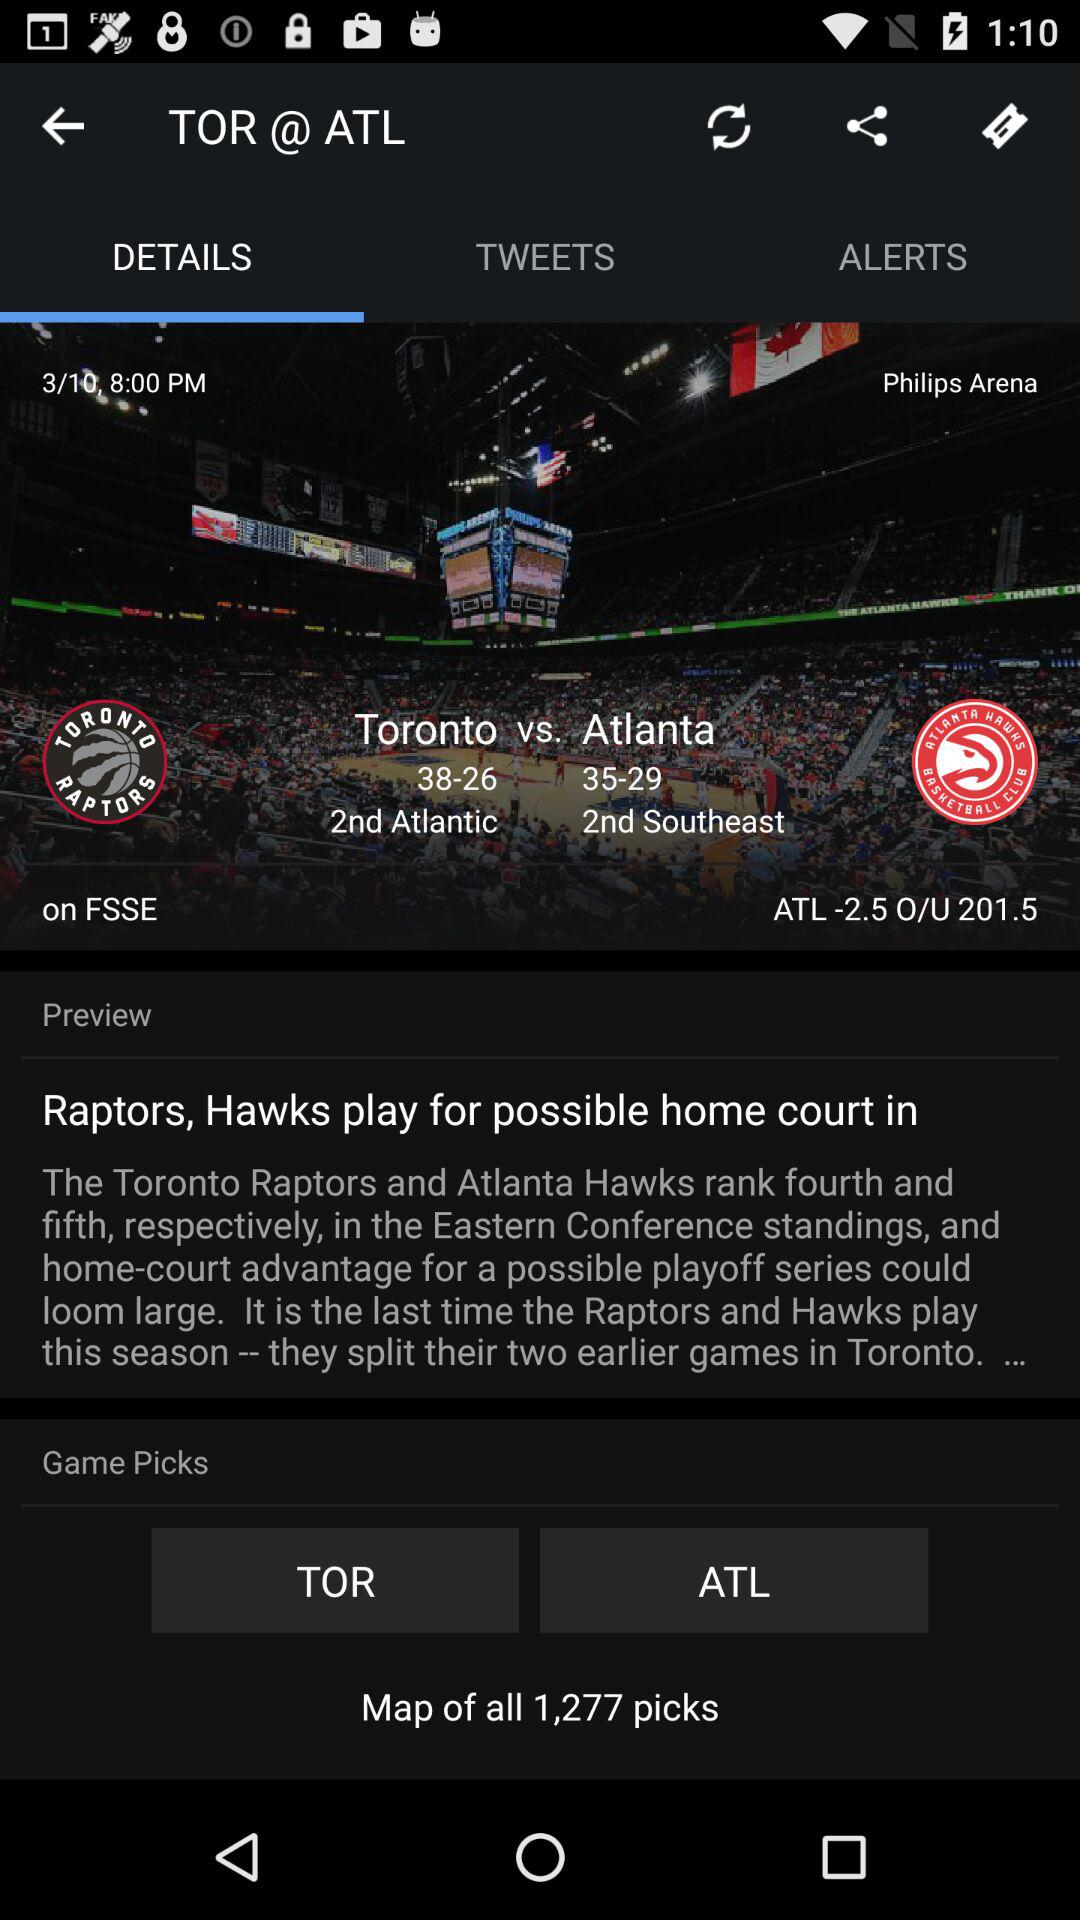What is the timing given for the post? The time given for the post is 8:00 PM. 